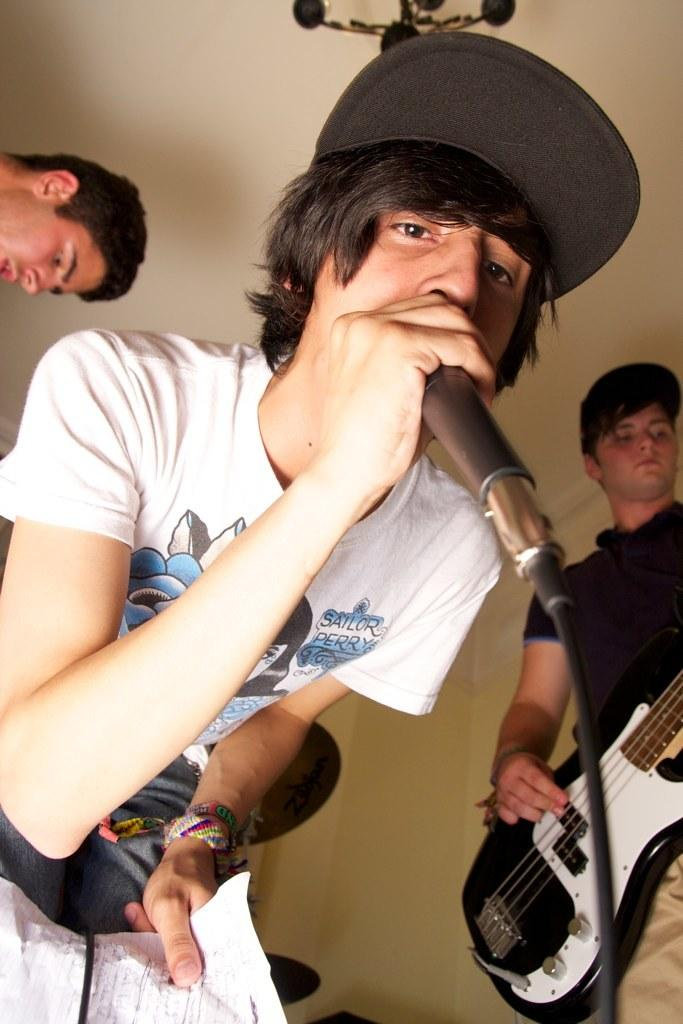Who is the main subject in the image? There is a boy in the image. What is the boy wearing? The boy is wearing a cap. What is the boy doing in the image? The boy is singing on a microphone. Are there any other people in the image? Yes, there is a guy in the image. What is the guy doing? The guy is playing a guitar. Can you see a goat playing the banjo in the image? No, there is no goat or banjo present in the image. 